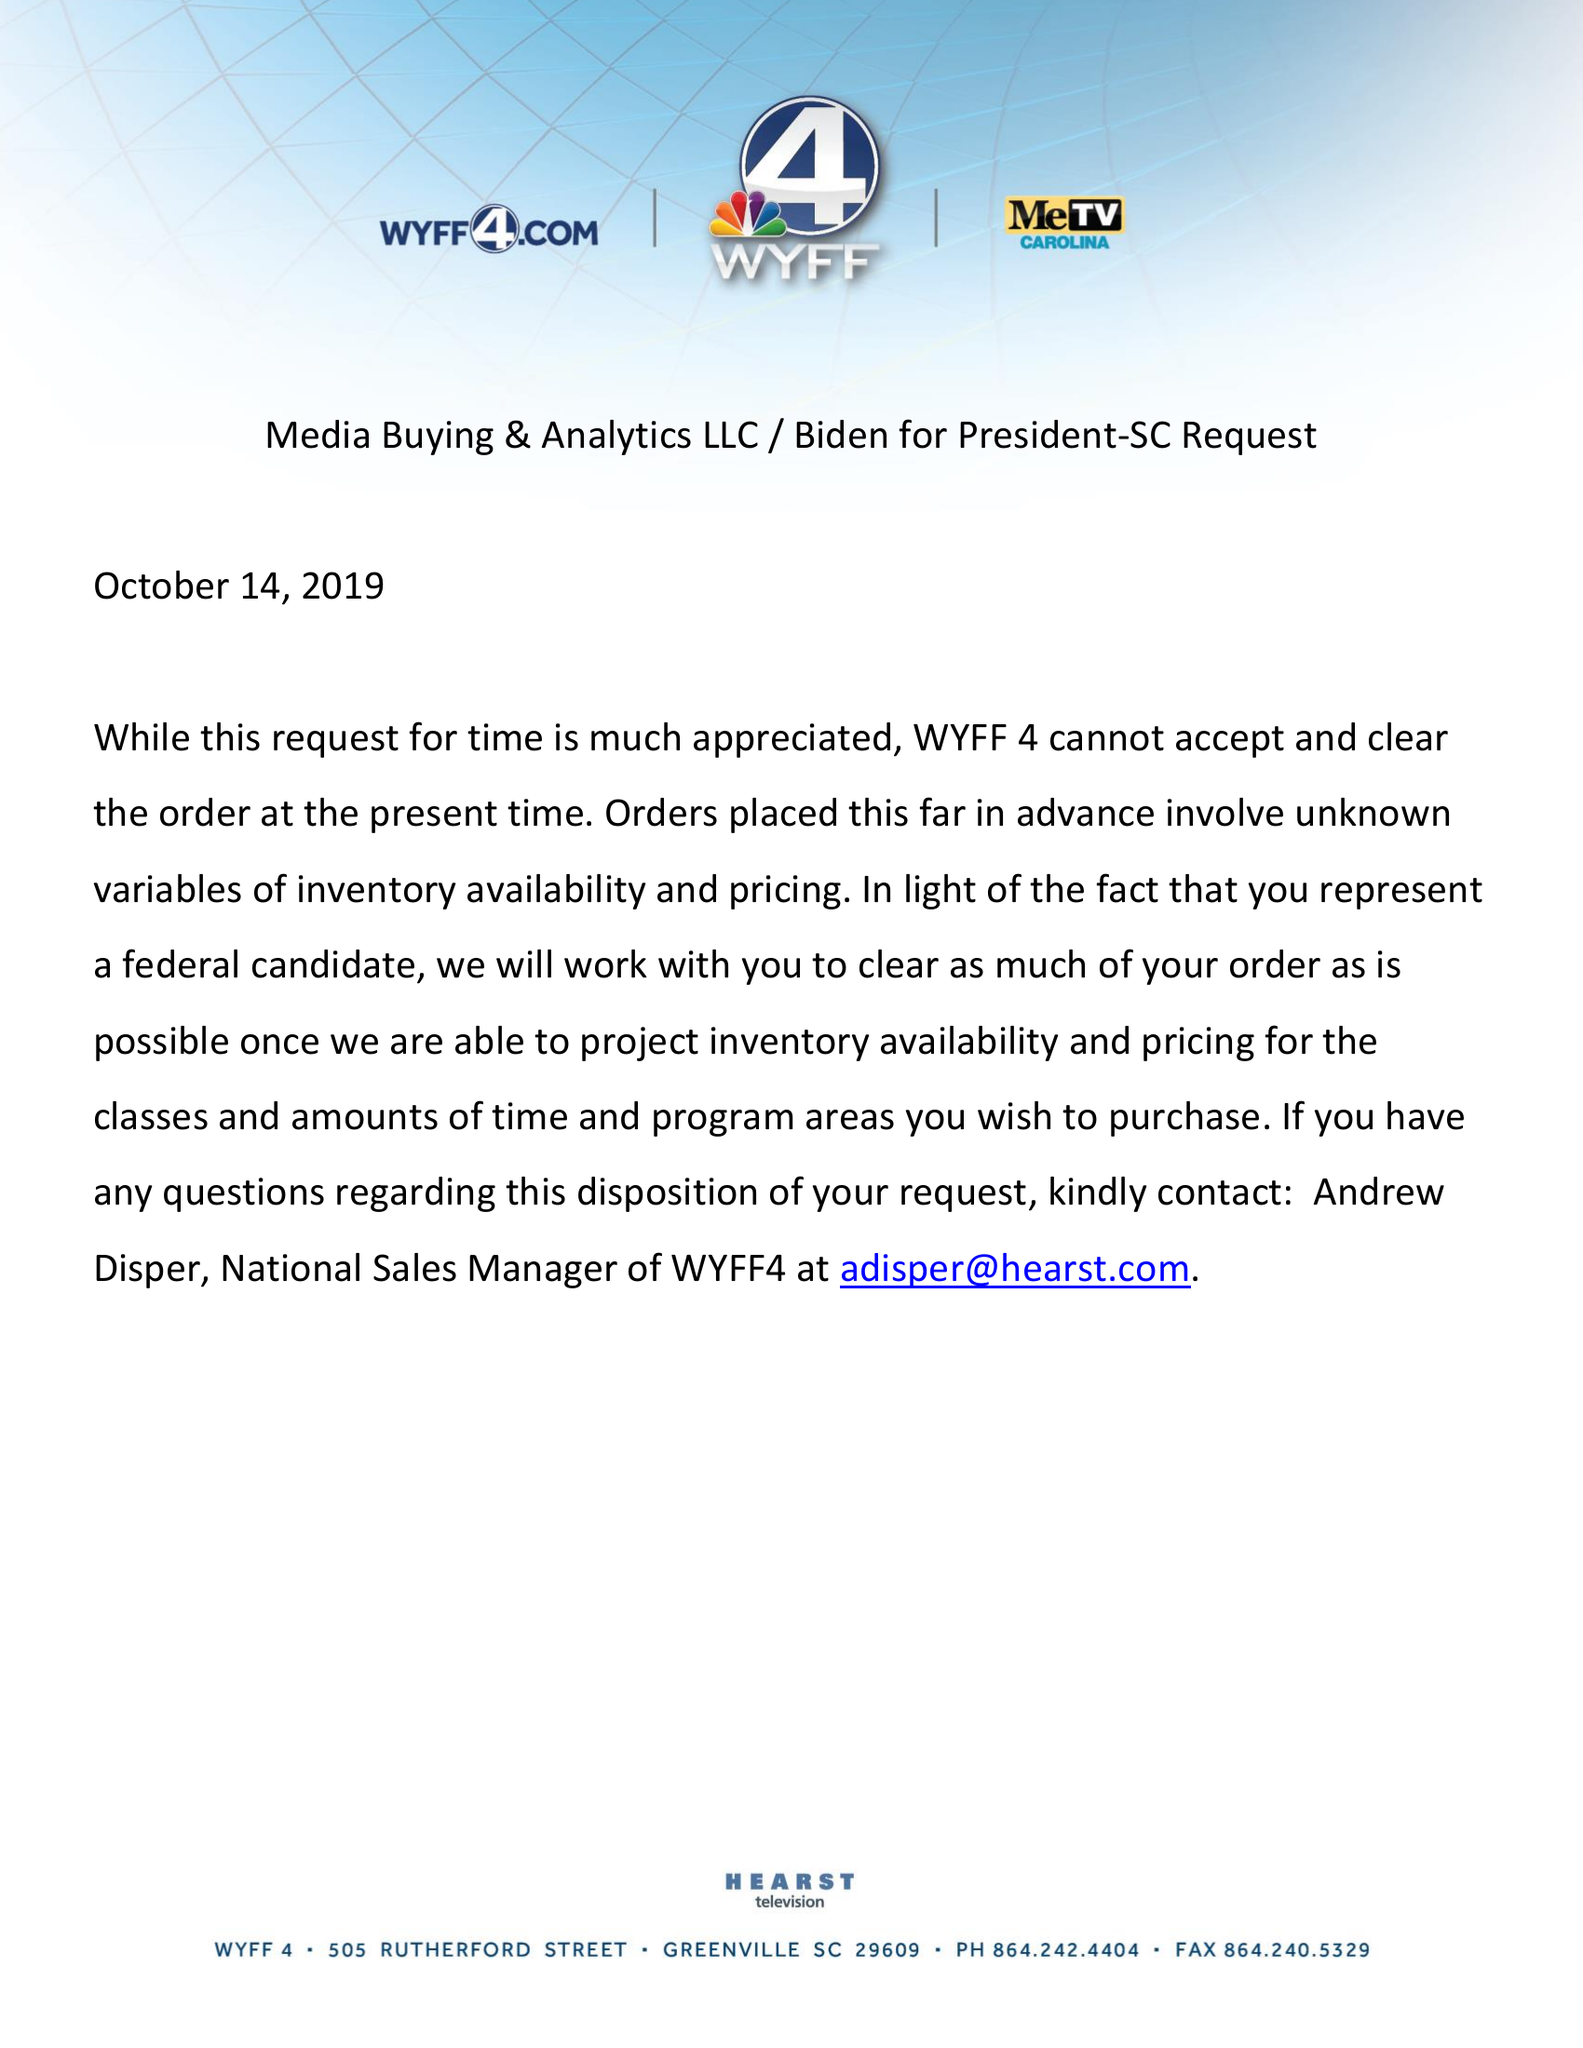What is the value for the gross_amount?
Answer the question using a single word or phrase. None 